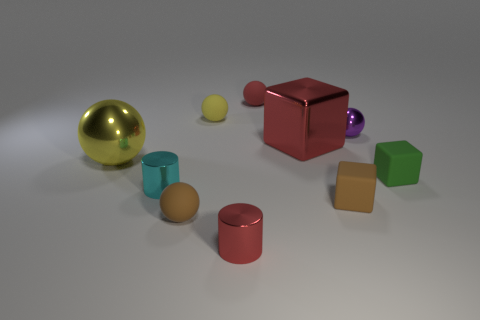Subtract all green blocks. How many blocks are left? 2 Subtract all purple metal balls. How many balls are left? 4 Add 9 small brown matte balls. How many small brown matte balls are left? 10 Add 2 red rubber objects. How many red rubber objects exist? 3 Subtract 1 red cubes. How many objects are left? 9 Subtract all blocks. How many objects are left? 7 Subtract 1 blocks. How many blocks are left? 2 Subtract all yellow balls. Subtract all green cylinders. How many balls are left? 3 Subtract all gray balls. How many red blocks are left? 1 Subtract all tiny red matte objects. Subtract all tiny green objects. How many objects are left? 8 